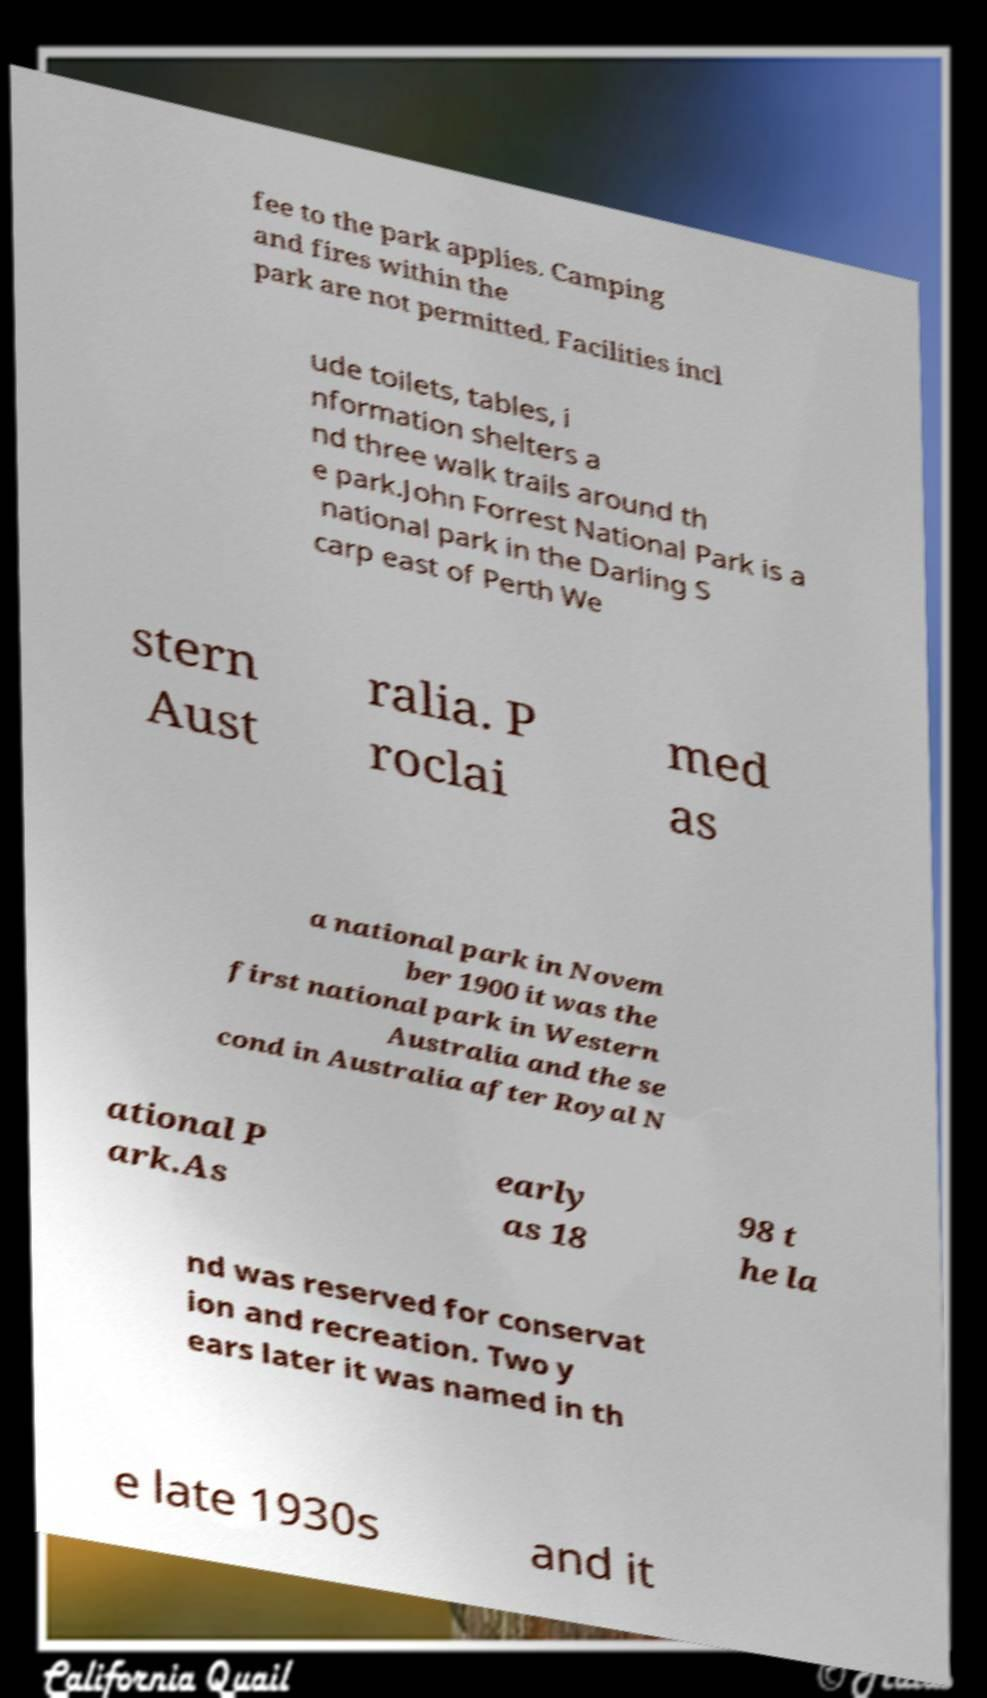Can you read and provide the text displayed in the image?This photo seems to have some interesting text. Can you extract and type it out for me? fee to the park applies. Camping and fires within the park are not permitted. Facilities incl ude toilets, tables, i nformation shelters a nd three walk trails around th e park.John Forrest National Park is a national park in the Darling S carp east of Perth We stern Aust ralia. P roclai med as a national park in Novem ber 1900 it was the first national park in Western Australia and the se cond in Australia after Royal N ational P ark.As early as 18 98 t he la nd was reserved for conservat ion and recreation. Two y ears later it was named in th e late 1930s and it 